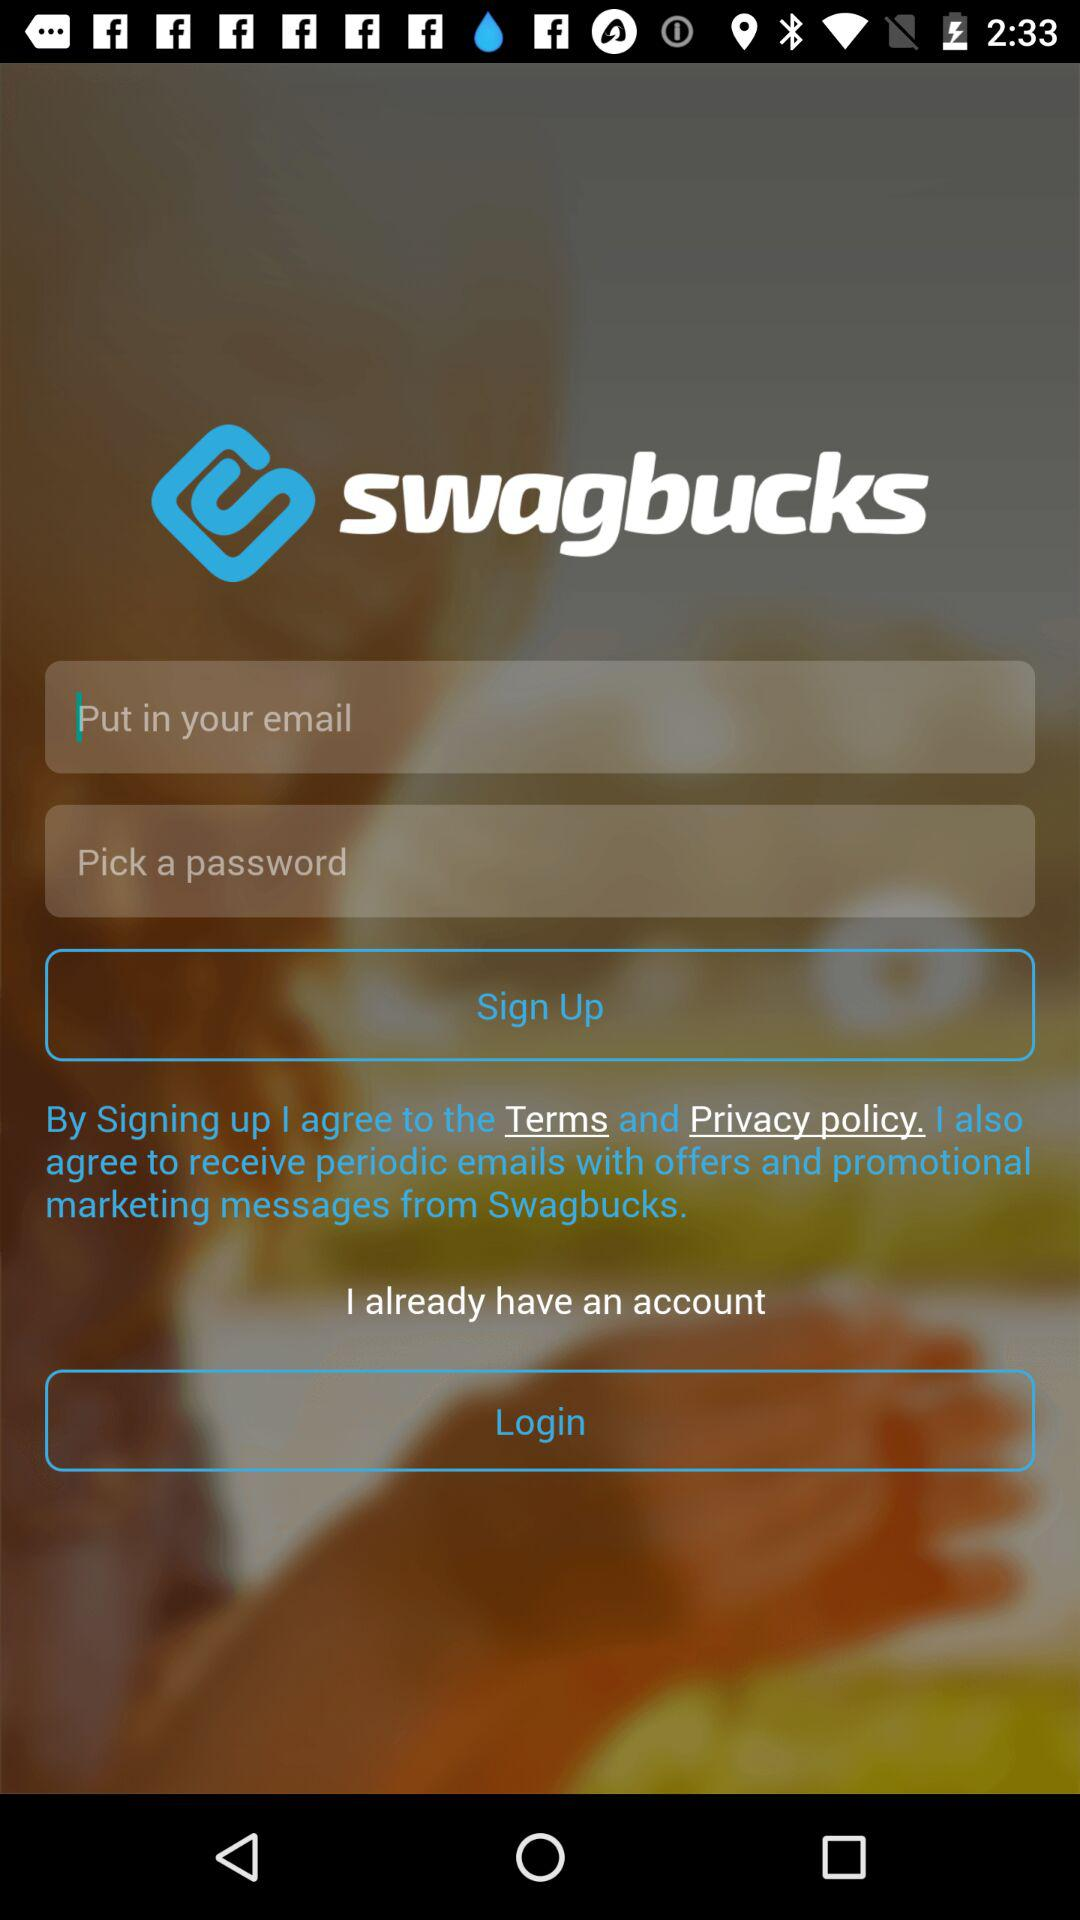What is the name of the application? The name of the application is "swagbucks". 